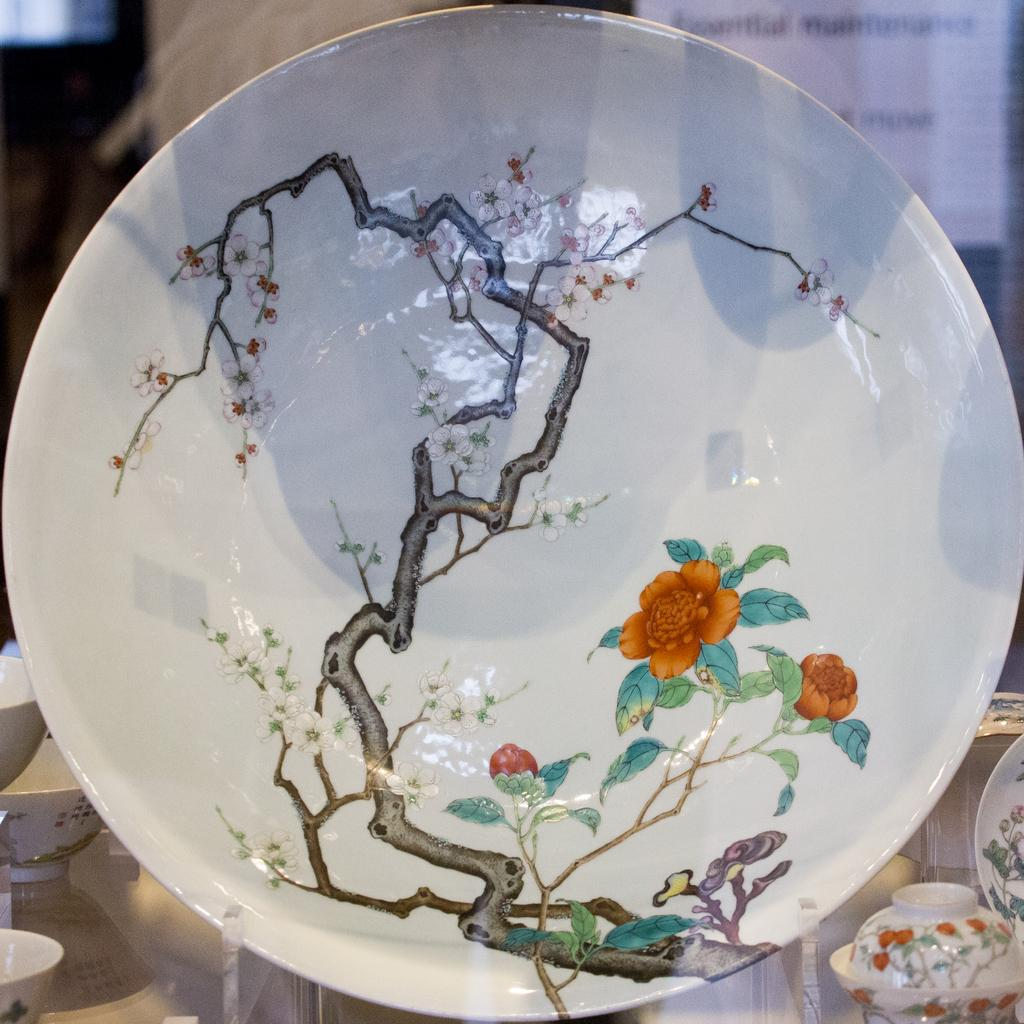What is the main subject of the image? There is a plate with a painting in the image. Can you describe any other objects in the background of the image? There are bowls in the background of the image, as well as other objects. What type of snail can be seen crawling on the plate in the image? There is no snail present in the image; the main subject is a plate with a painting. 